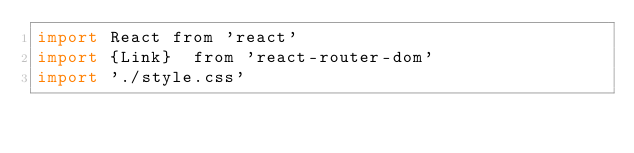Convert code to text. <code><loc_0><loc_0><loc_500><loc_500><_JavaScript_>import React from 'react'
import {Link}  from 'react-router-dom'
import './style.css'
</code> 